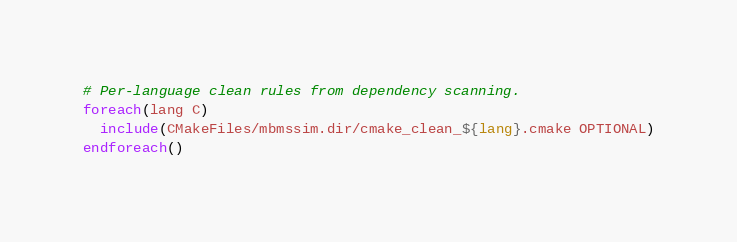Convert code to text. <code><loc_0><loc_0><loc_500><loc_500><_CMake_>
# Per-language clean rules from dependency scanning.
foreach(lang C)
  include(CMakeFiles/mbmssim.dir/cmake_clean_${lang}.cmake OPTIONAL)
endforeach()
</code> 